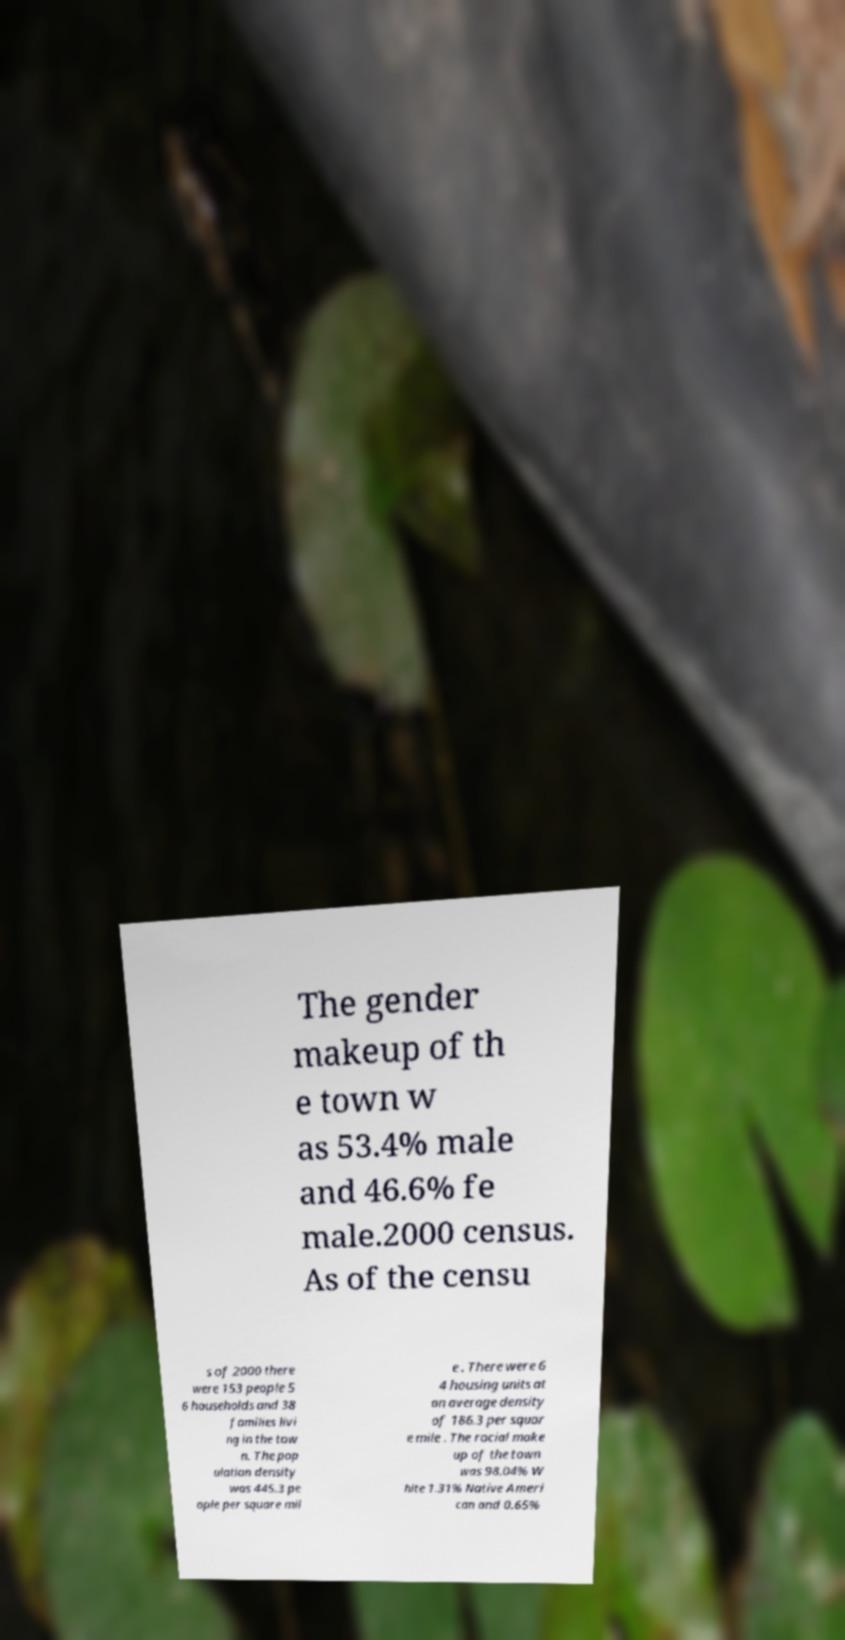Please read and relay the text visible in this image. What does it say? The gender makeup of th e town w as 53.4% male and 46.6% fe male.2000 census. As of the censu s of 2000 there were 153 people 5 6 households and 38 families livi ng in the tow n. The pop ulation density was 445.3 pe ople per square mil e . There were 6 4 housing units at an average density of 186.3 per squar e mile . The racial make up of the town was 98.04% W hite 1.31% Native Ameri can and 0.65% 